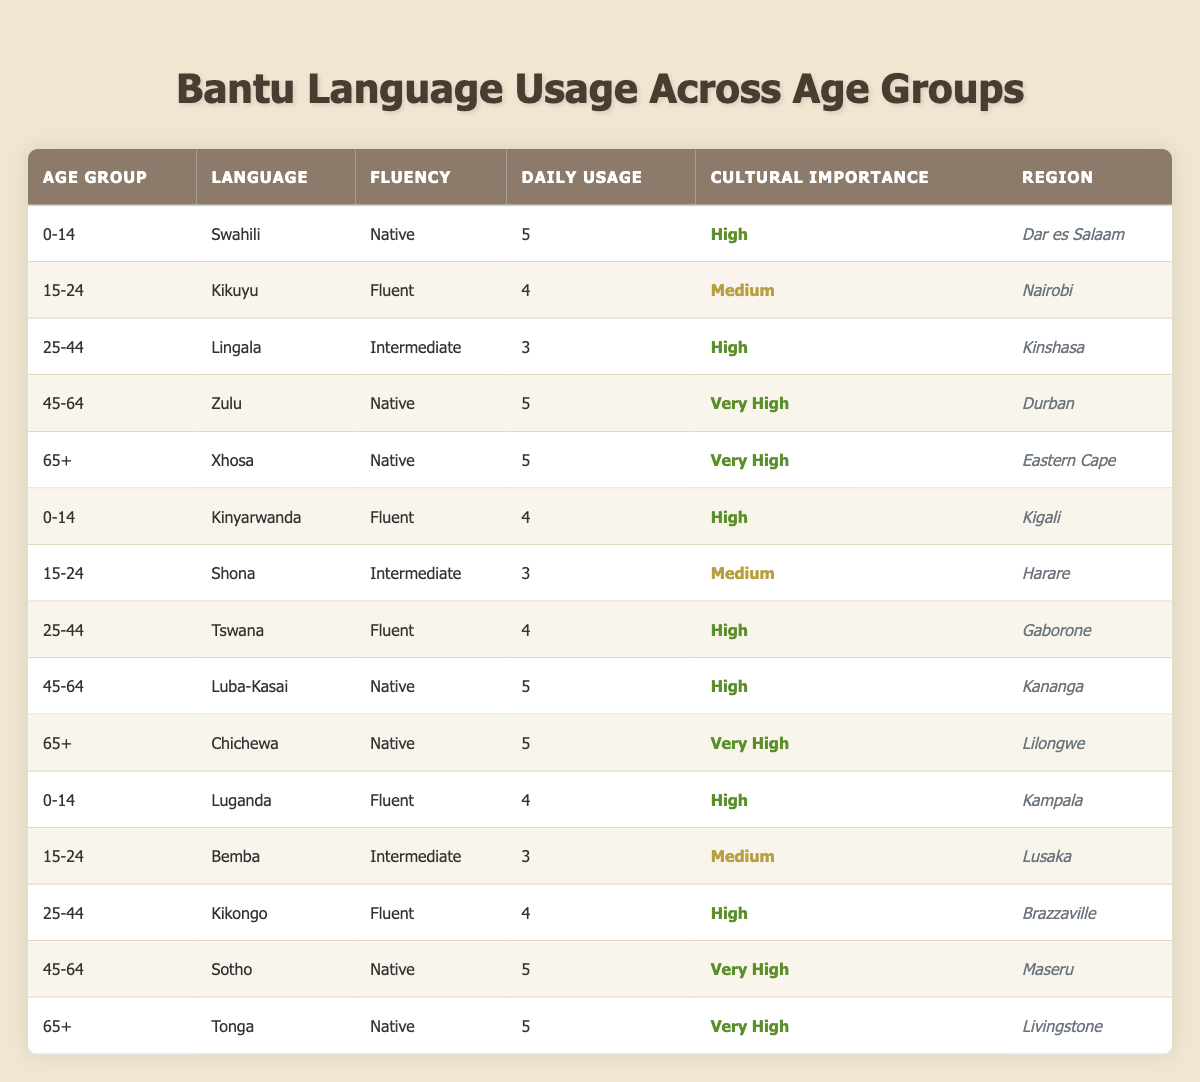What is the most frequently used language in the 0-14 age group? The 0-14 age group has three languages listed: Swahili (Daily Usage = 5), Kinyarwanda (Daily Usage = 4), and Luganda (Daily Usage = 4). The highest daily usage is for Swahili at 5.
Answer: Swahili Which language in the 45-64 age group has the highest cultural importance? In the 45-64 age group, there are three languages: Zulu (Cultural Importance = Very High), Luba-Kasai (Cultural Importance = High), and Sotho (Cultural Importance = Very High). Zulu and Sotho both have Very High cultural importance, but Zulu has the highest daily usage (5).
Answer: Zulu What is the average daily usage of Bantu languages for the 25-44 age group? In the 25-44 age group, the daily usage entries are: Lingala (3), Tswana (4), and Kikongo (4). Calculating the average: (3 + 4 + 4) / 3 = 11 / 3 ≈ 3.67.
Answer: Approximately 3.67 Is Kinyarwanda used more than Kikuyu in the community based on daily usage? Kinyarwanda has a daily usage of 4, while Kikuyu has a daily usage of 4 in the 15-24 age group. Since they are equal, Kinyarwanda is not used more than Kikuyu.
Answer: No What is the total daily usage of languages in the 65+ age group? The 65+ age group shows three languages: Xhosa (5), Chichewa (5), and Tonga (5). Totaling these gives: 5 + 5 + 5 = 15.
Answer: 15 Which language has the highest fluency in the 15-24 age group? In the 15-24 age group, the languages are Kikuyu (Fluent), Shona (Intermediate), and Bemba (Intermediate). Since Kikuyu is Fluent, it has the highest fluency in this age group.
Answer: Kikuyu Is it true that all languages with Very High cultural importance are used daily? The languages with Very High cultural importance are Zulu, Chichewa, and Tonga, all of which have a daily usage of 5. Thus, it is true that they are used daily.
Answer: Yes What is the cultural significance of the languages spoken in the 45-64 age group? The 45-64 age group languages are Zulu (Very High), Luba-Kasai (High), and Sotho (Very High). The cultural significance includes two Very High and one High cultural importance. This indicates a strong cultural significance overall.
Answer: Very High and High 